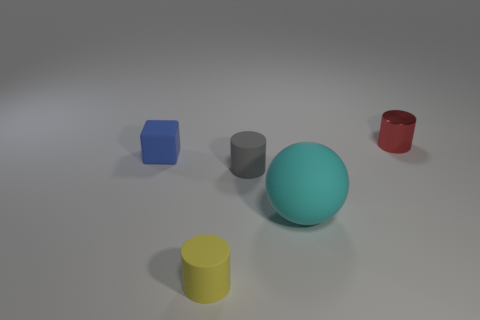Are there any other things that have the same size as the matte sphere?
Make the answer very short. No. Are there more small metal things that are behind the cyan sphere than tiny cylinders on the left side of the blue cube?
Provide a short and direct response. Yes. Are there any purple shiny blocks that have the same size as the cyan matte thing?
Offer a very short reply. No. There is a cylinder that is behind the tiny matte object left of the matte cylinder that is to the left of the small gray cylinder; what is its size?
Offer a very short reply. Small. What color is the big thing?
Offer a very short reply. Cyan. Is the number of blue things that are on the right side of the yellow object greater than the number of big green rubber cubes?
Keep it short and to the point. No. There is a blue matte thing; what number of cyan rubber balls are on the left side of it?
Offer a terse response. 0. Is there a matte cylinder behind the cylinder behind the thing that is to the left of the small yellow object?
Your response must be concise. No. Is the gray matte cylinder the same size as the ball?
Give a very brief answer. No. Are there an equal number of tiny cylinders behind the tiny blue block and small matte cubes in front of the tiny gray rubber object?
Provide a succinct answer. No. 